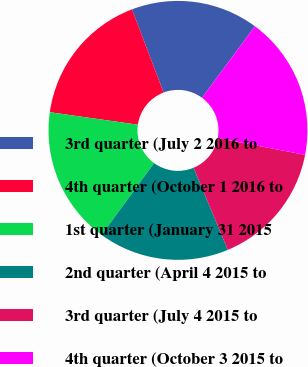Convert chart to OTSL. <chart><loc_0><loc_0><loc_500><loc_500><pie_chart><fcel>3rd quarter (July 2 2016 to<fcel>4th quarter (October 1 2016 to<fcel>1st quarter (January 31 2015<fcel>2nd quarter (April 4 2015 to<fcel>3rd quarter (July 4 2015 to<fcel>4th quarter (October 3 2015 to<nl><fcel>15.91%<fcel>16.98%<fcel>17.2%<fcel>16.34%<fcel>15.68%<fcel>17.9%<nl></chart> 